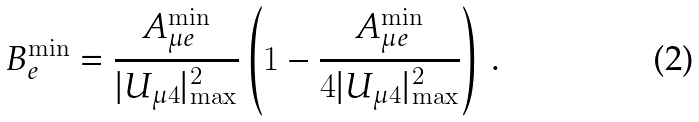<formula> <loc_0><loc_0><loc_500><loc_500>B _ { e } ^ { \min } = \frac { A _ { { \mu } e } ^ { \min } } { | U _ { \mu 4 } | ^ { 2 } _ { \max } } \left ( 1 - \frac { A _ { { \mu } e } ^ { \min } } { 4 | U _ { \mu 4 } | ^ { 2 } _ { \max } } \right ) \, .</formula> 